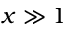<formula> <loc_0><loc_0><loc_500><loc_500>x \gg 1</formula> 